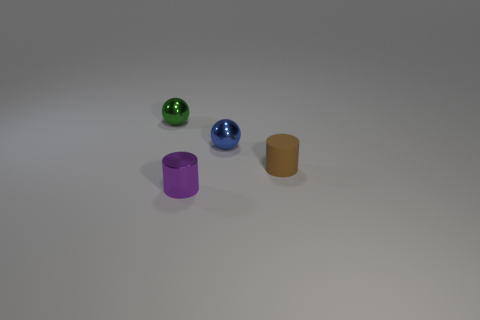Add 4 tiny green metal things. How many objects exist? 8 Subtract 2 cylinders. How many cylinders are left? 0 Subtract all cyan cylinders. Subtract all yellow blocks. How many cylinders are left? 2 Subtract all yellow cylinders. How many yellow balls are left? 0 Subtract all tiny green metallic balls. Subtract all tiny purple things. How many objects are left? 2 Add 2 brown cylinders. How many brown cylinders are left? 3 Add 1 small blue metal balls. How many small blue metal balls exist? 2 Subtract all brown cylinders. How many cylinders are left? 1 Subtract 0 yellow cylinders. How many objects are left? 4 